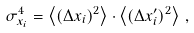<formula> <loc_0><loc_0><loc_500><loc_500>\sigma _ { x _ { i } } ^ { 4 } = \left < ( \Delta x _ { i } ) ^ { 2 } \right > \cdot \left < ( \Delta x _ { i } ^ { \prime } ) ^ { 2 } \right > \, ,</formula> 